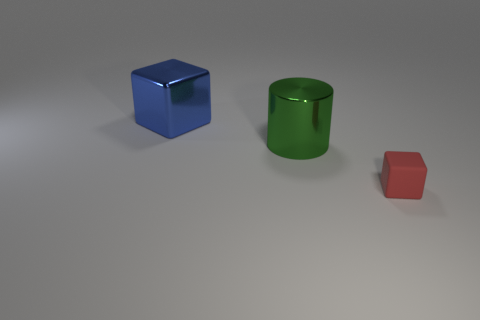Subtract all blue balls. How many blue cylinders are left? 0 Add 3 tiny cubes. How many objects exist? 6 Subtract all blue cubes. How many cubes are left? 1 Subtract 1 red blocks. How many objects are left? 2 Subtract all blocks. How many objects are left? 1 Subtract 1 cubes. How many cubes are left? 1 Subtract all blue blocks. Subtract all purple cylinders. How many blocks are left? 1 Subtract all large gray cylinders. Subtract all large shiny things. How many objects are left? 1 Add 3 small rubber blocks. How many small rubber blocks are left? 4 Add 3 large blue cubes. How many large blue cubes exist? 4 